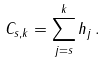<formula> <loc_0><loc_0><loc_500><loc_500>C _ { s , k } = \sum _ { j = s } ^ { k } h _ { j } \, .</formula> 